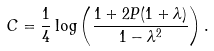Convert formula to latex. <formula><loc_0><loc_0><loc_500><loc_500>C = \frac { 1 } { 4 } \log \left ( \frac { 1 + 2 P ( 1 + \lambda ) } { 1 - \lambda ^ { 2 } } \right ) .</formula> 